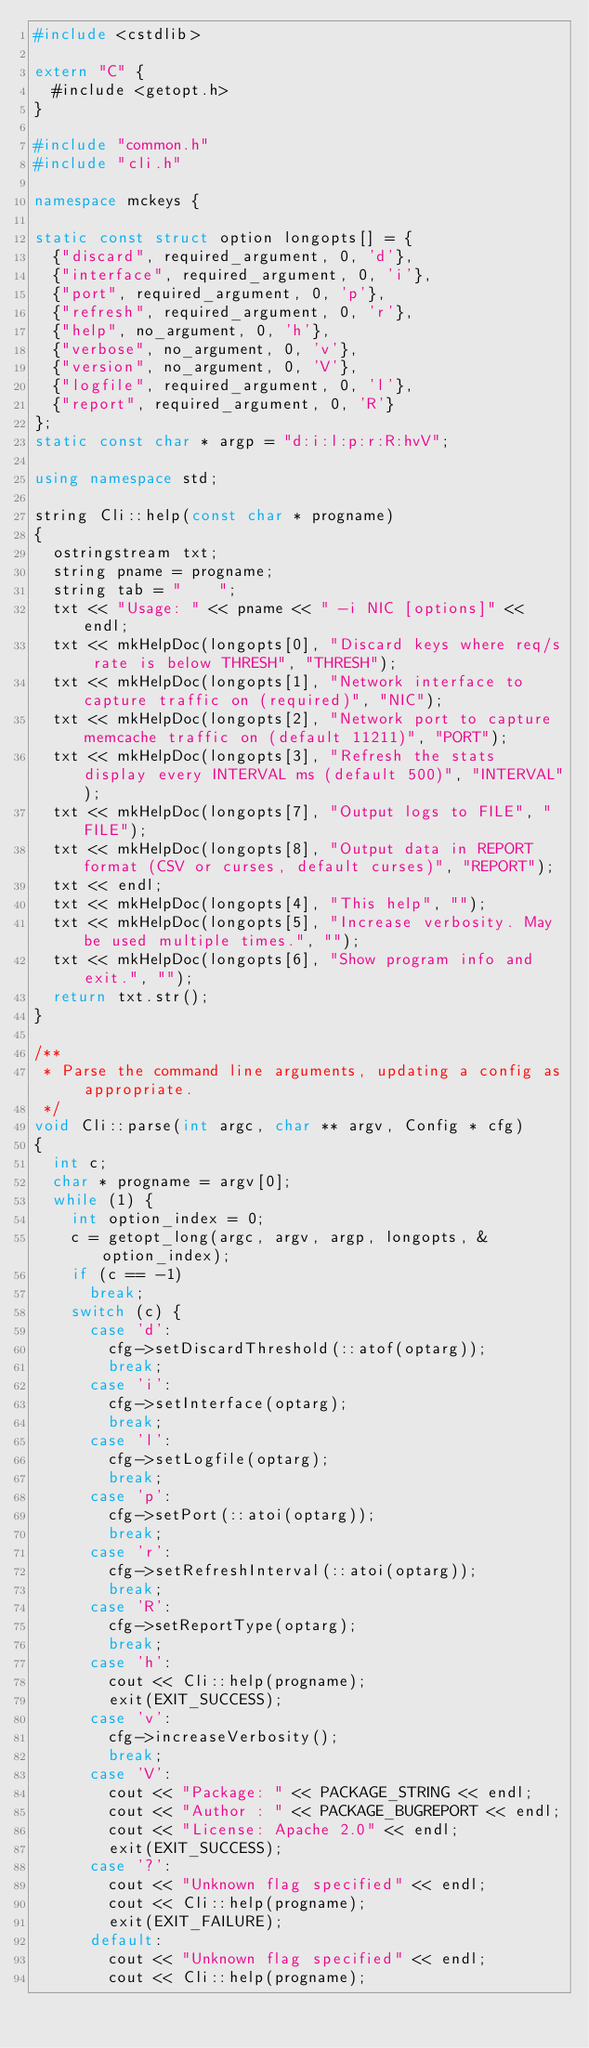Convert code to text. <code><loc_0><loc_0><loc_500><loc_500><_C++_>#include <cstdlib>

extern "C" {
  #include <getopt.h>
}

#include "common.h"
#include "cli.h"

namespace mckeys {

static const struct option longopts[] = {
  {"discard", required_argument, 0, 'd'},
  {"interface", required_argument, 0, 'i'},
  {"port", required_argument, 0, 'p'},
  {"refresh", required_argument, 0, 'r'},
  {"help", no_argument, 0, 'h'},
  {"verbose", no_argument, 0, 'v'},
  {"version", no_argument, 0, 'V'},
  {"logfile", required_argument, 0, 'l'},
  {"report", required_argument, 0, 'R'}
};
static const char * argp = "d:i:l:p:r:R:hvV";

using namespace std;

string Cli::help(const char * progname)
{
  ostringstream txt;
  string pname = progname;
  string tab = "    ";
  txt << "Usage: " << pname << " -i NIC [options]" << endl;
  txt << mkHelpDoc(longopts[0], "Discard keys where req/s rate is below THRESH", "THRESH");
  txt << mkHelpDoc(longopts[1], "Network interface to capture traffic on (required)", "NIC");
  txt << mkHelpDoc(longopts[2], "Network port to capture memcache traffic on (default 11211)", "PORT");
  txt << mkHelpDoc(longopts[3], "Refresh the stats display every INTERVAL ms (default 500)", "INTERVAL");
  txt << mkHelpDoc(longopts[7], "Output logs to FILE", "FILE");
  txt << mkHelpDoc(longopts[8], "Output data in REPORT format (CSV or curses, default curses)", "REPORT");
  txt << endl;
  txt << mkHelpDoc(longopts[4], "This help", "");
  txt << mkHelpDoc(longopts[5], "Increase verbosity. May be used multiple times.", "");
  txt << mkHelpDoc(longopts[6], "Show program info and exit.", "");
  return txt.str();
}

/**
 * Parse the command line arguments, updating a config as appropriate.
 */
void Cli::parse(int argc, char ** argv, Config * cfg)
{
  int c;
  char * progname = argv[0];
  while (1) {
    int option_index = 0;
    c = getopt_long(argc, argv, argp, longopts, &option_index);
    if (c == -1)
      break;
    switch (c) {
      case 'd':
        cfg->setDiscardThreshold(::atof(optarg));
        break;
      case 'i':
        cfg->setInterface(optarg);
        break;
      case 'l':
        cfg->setLogfile(optarg);
        break;
      case 'p':
        cfg->setPort(::atoi(optarg));
        break;
      case 'r':
        cfg->setRefreshInterval(::atoi(optarg));
        break;
      case 'R':
        cfg->setReportType(optarg);
        break;
      case 'h':
        cout << Cli::help(progname);
        exit(EXIT_SUCCESS);
      case 'v':
        cfg->increaseVerbosity();
        break;
      case 'V':
        cout << "Package: " << PACKAGE_STRING << endl;
        cout << "Author : " << PACKAGE_BUGREPORT << endl;
        cout << "License: Apache 2.0" << endl;
        exit(EXIT_SUCCESS);
      case '?':
        cout << "Unknown flag specified" << endl;
        cout << Cli::help(progname);
        exit(EXIT_FAILURE);
      default:
        cout << "Unknown flag specified" << endl;
        cout << Cli::help(progname);</code> 